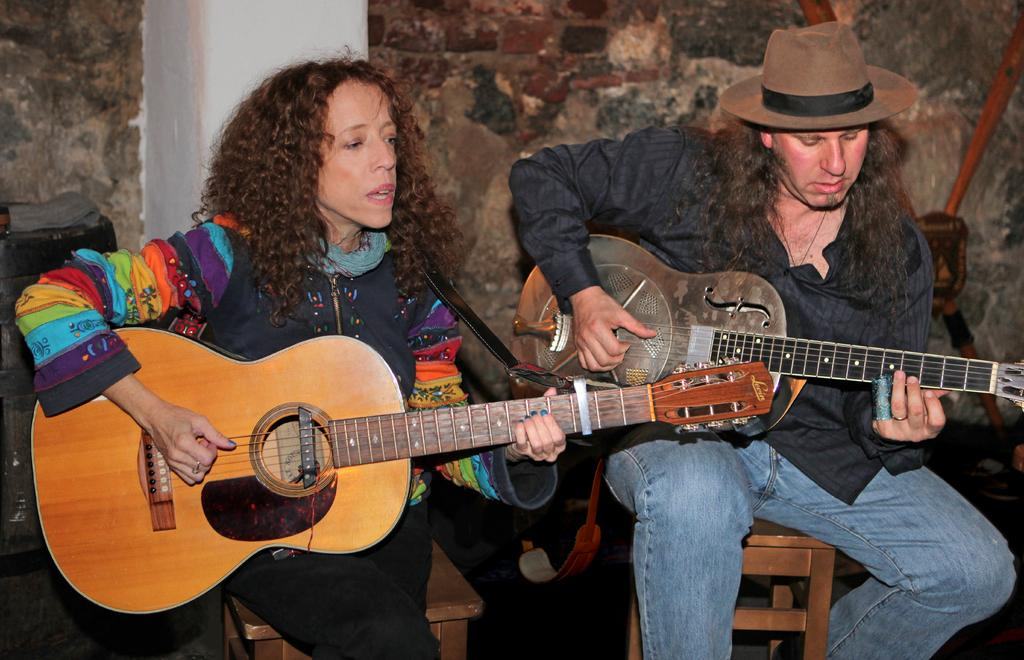How many people are in the image? There are two people in the image. What are the two people doing in the image? The two people are playing musical instruments. What type of animal can be seen playing a musical instrument in the image? There are no animals present in the image, and therefore no animal is playing a musical instrument. 